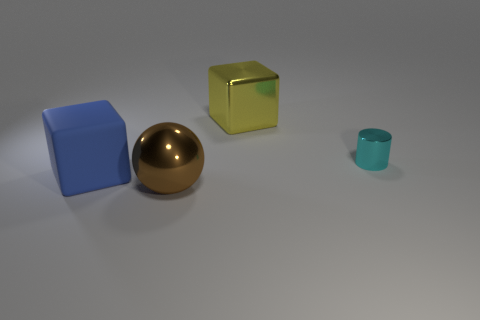Add 4 metallic cylinders. How many objects exist? 8 Subtract 1 blocks. How many blocks are left? 1 Subtract all blue cubes. How many cubes are left? 1 Subtract 0 red balls. How many objects are left? 4 Subtract all cylinders. How many objects are left? 3 Subtract all yellow spheres. Subtract all blue cylinders. How many spheres are left? 1 Subtract all purple cylinders. How many yellow blocks are left? 1 Subtract all large yellow metal cubes. Subtract all blue rubber blocks. How many objects are left? 2 Add 2 small shiny cylinders. How many small shiny cylinders are left? 3 Add 3 small spheres. How many small spheres exist? 3 